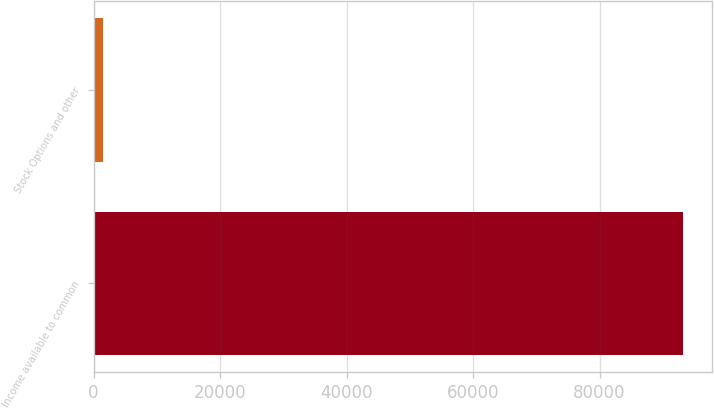Convert chart. <chart><loc_0><loc_0><loc_500><loc_500><bar_chart><fcel>Income available to common<fcel>Stock Options and other<nl><fcel>93145<fcel>1467<nl></chart> 